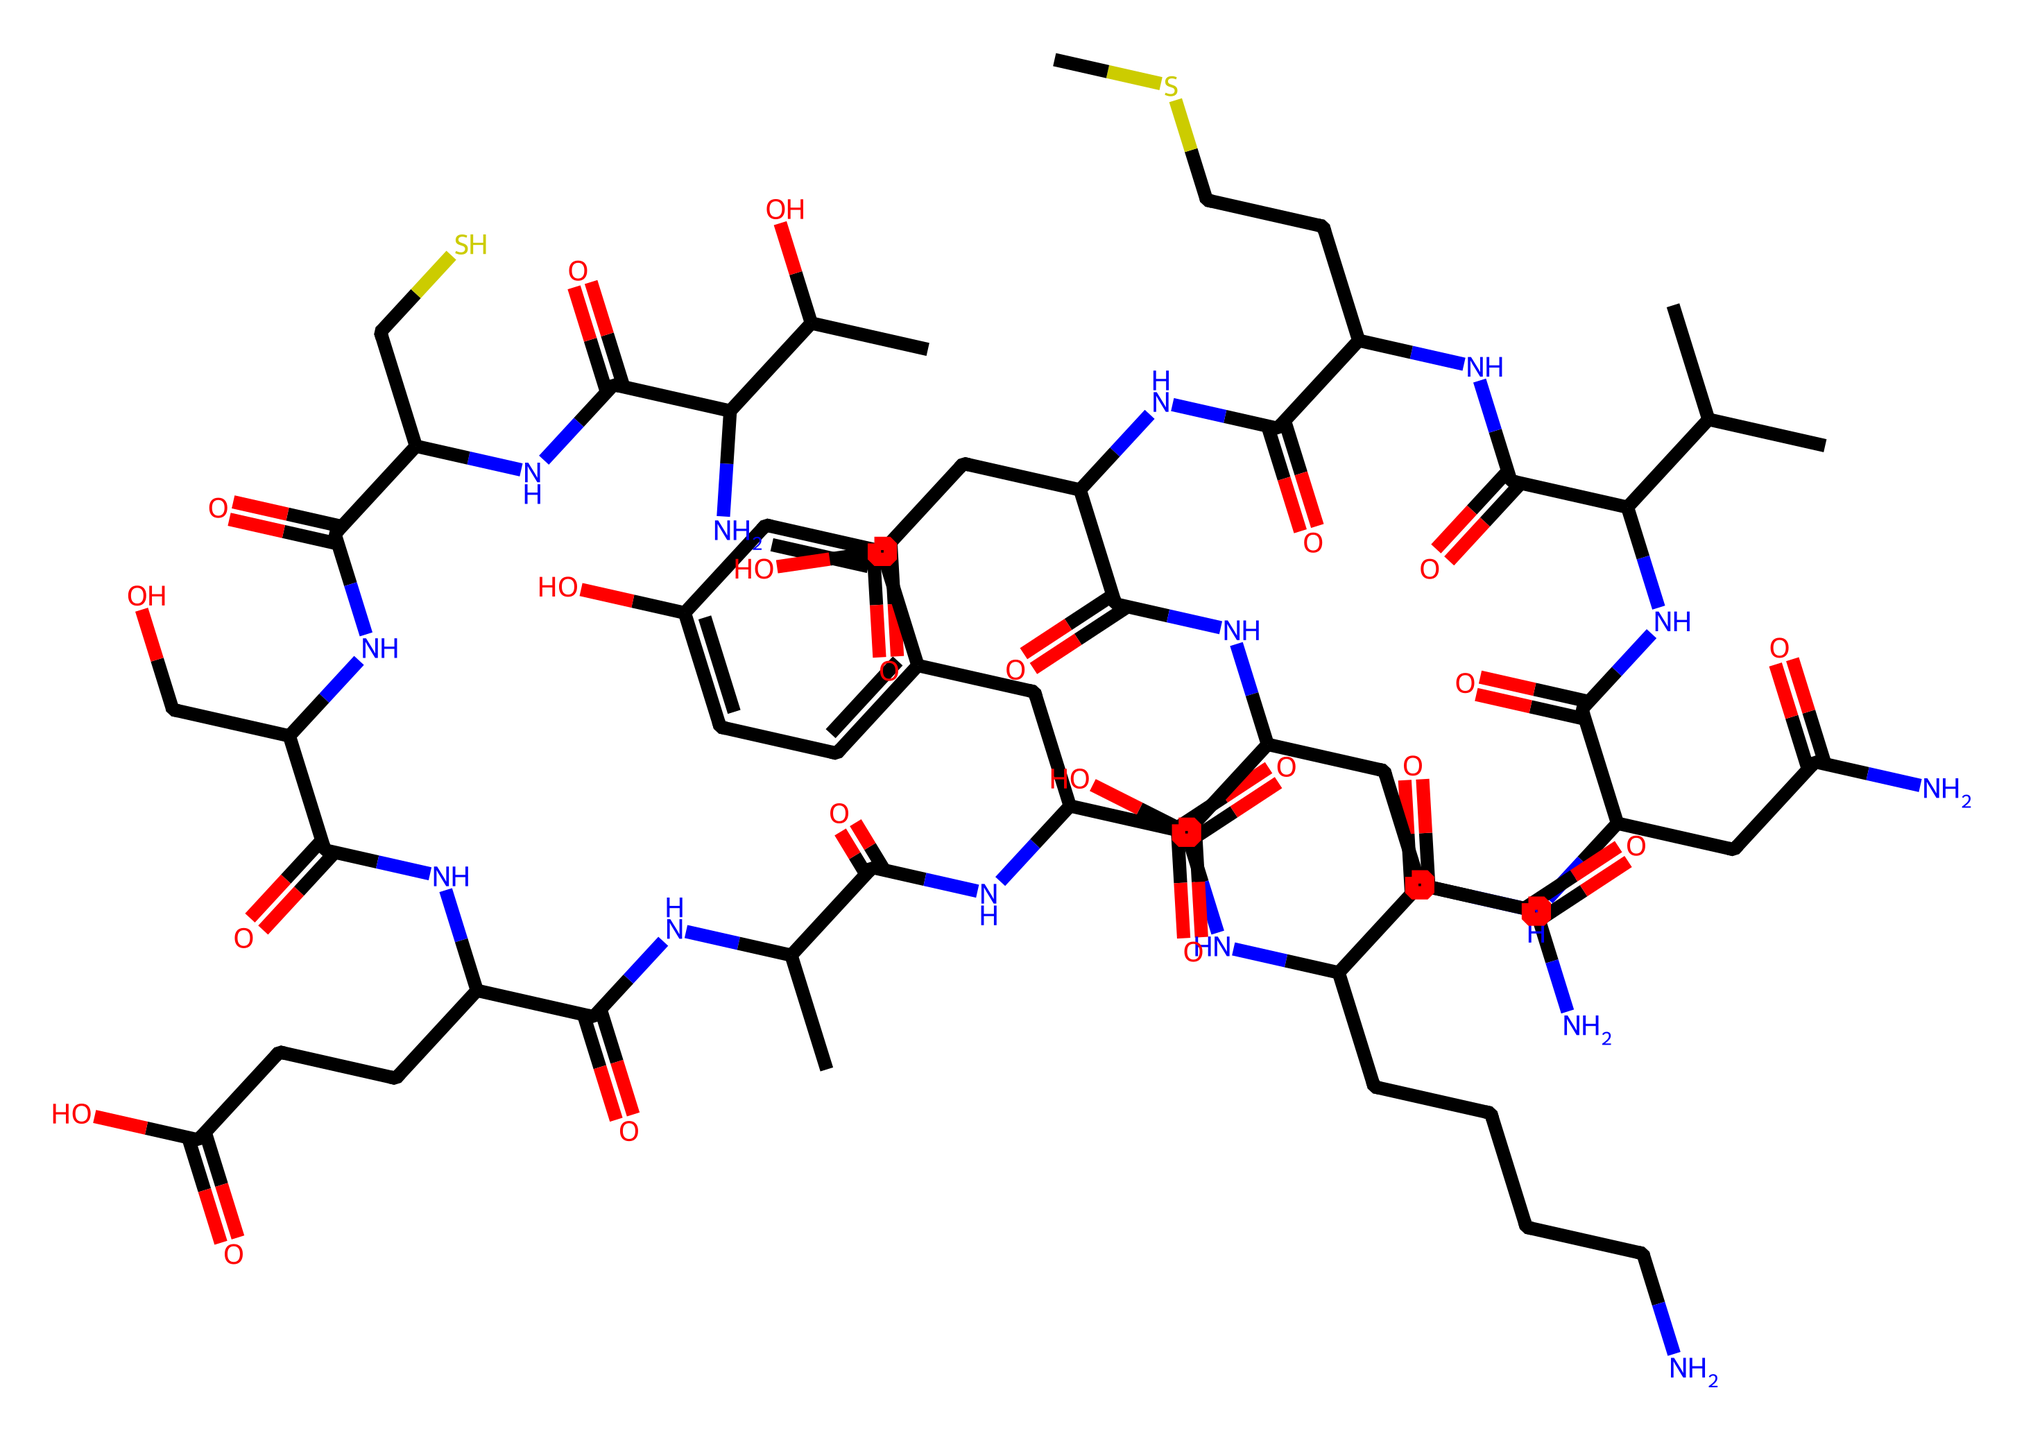What is the total number of carbon atoms in the structure? By counting the carbon atoms represented in the SMILES string, we identify 24 carbon atoms in total.
Answer: 24 How many nitrogen atoms are present in the chemical? The nitrogen atoms in the SMILES string can be counted, resulting in a total of 6 nitrogen atoms in the structure.
Answer: 6 What functional groups are predominant in this chemical? The chemical contains multiple amides (due to the nitrogen and carbonyl connections) and hydroxyl (OH) groups, making amides and alcohols the predominant functional groups.
Answer: amides and alcohols What is the main type of fiber represented by this chemical? The structure suggests the presence of protein-based fibers, as evidenced by the amino acids contained (indicated by nitrogen), which are commonly found in natural fibers like wool.
Answer: protein-based fibers How does the presence of β-sheet structures affect the properties of wool? The β-sheet structures, formed by hydrogen bonding between amide groups in the protein, contribute to the tensile strength and resilience of the wool fiber.
Answer: tensile strength and resilience What factor affects the scalability of wool fiber production as indicated by this structure? The presence of multiple functional groups, such as amides that require careful processing, can limit scalability due to the complexity of extraction and processing methods.
Answer: processing complexity Which part of the chemical structure contributes to the hydrophilic nature of wool? The hydroxyl (OH) groups in the structure introduce polar characteristics, making the chemical more hydrophilic and enhancing water absorption properties of wool fibers.
Answer: hydroxyl groups 